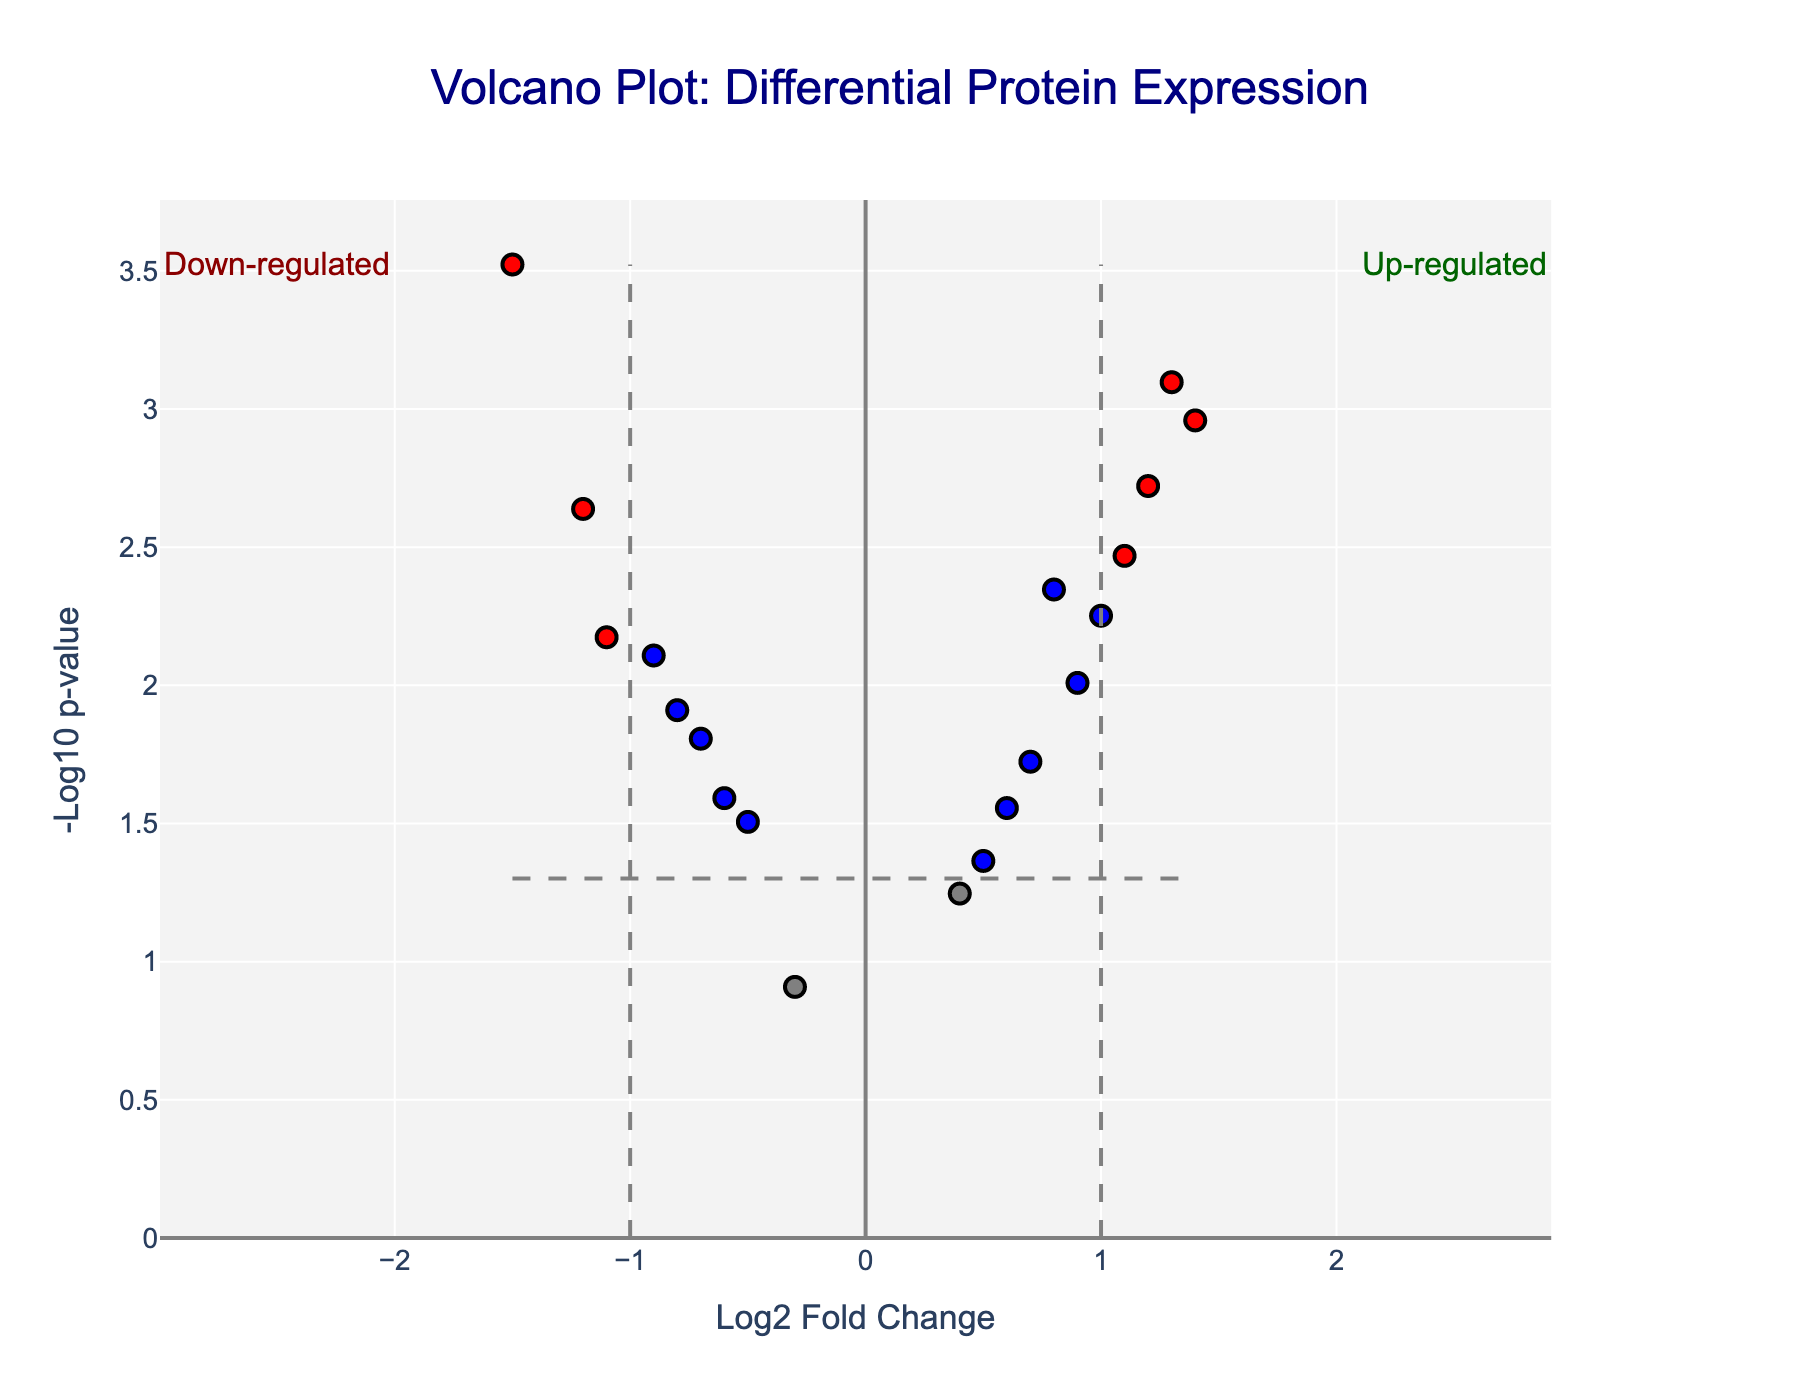What is the title of the plot? The title of the plot is typically displayed at the top of the figure. In this case, it is "Volcano Plot: Differential Protein Expression".
Answer: Volcano Plot: Differential Protein Expression What are the axes labels? The axes labels are usually displayed alongside the axes. In this plot, the x-axis label is "Log2 Fold Change" and the y-axis label is "-Log10 p-value".
Answer: Log2 Fold Change; -Log10 p-value How many data points are there in total? To determine the total number of data points, we count the markers on the plot. Each marker represents a protein. From the provided data, there are 20 proteins.
Answer: 20 Which protein has the most significant p-value? The most significant p-value corresponds to the highest -Log10 p-value. In the figure, ICAM-1 has the highest -Log10 p-value value.
Answer: ICAM-1 Which proteins are significantly up-regulated? Proteins that are significantly up-regulated have log2 fold change greater than 1 and p-value less than 0.05 (red color on the right). From the plot, these proteins are IGF-1, CXCL8, HIF-1alpha, and BCL-2.
Answer: IGF-1, CXCL8, HIF-1alpha, BCL-2 Which proteins are significantly down-regulated? Proteins that are significantly down-regulated have log2 fold change less than -1 and p-value less than 0.05 (red color on the left). From the plot, these proteins are VEGF-A, TGF-beta1, ICAM-1, and STAT3.
Answer: VEGF-A, TGF-beta1, ICAM-1, STAT3 What is the significance threshold for the p-value? The significance threshold for the p-value is indicated by the horizontal dashed line on the plot. It is set at p-value = 0.05, corresponding to -Log10(0.05) which is 1.3.
Answer: 0.05 What does the grey color of data points signify? The grey color of data points indicates that the proteins are not significantly regulated, meaning their p-value is greater than 0.05 regardless of log2 fold change.
Answer: Not significantly regulated Which region on the plot represents up-regulated proteins? Up-regulated proteins are represented by the region on the right side of the vertical dashed line at log2 fold change = 1.
Answer: Right side Which region on the plot represents down-regulated proteins? Down-regulated proteins are represented by the region on the left side of the vertical dashed line at log2 fold change = -1.
Answer: Left side 